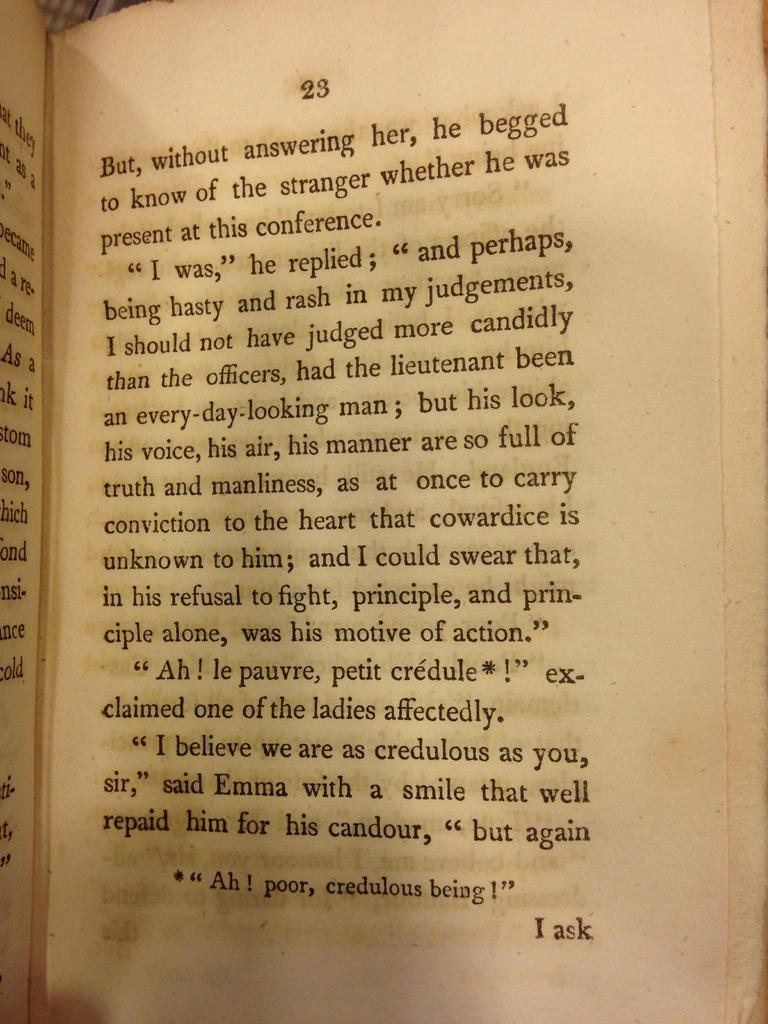<image>
Offer a succinct explanation of the picture presented. A book that is opened to page 23 that discusses various quotes. 